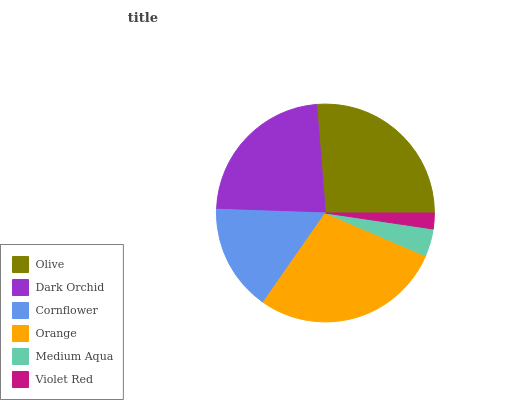Is Violet Red the minimum?
Answer yes or no. Yes. Is Orange the maximum?
Answer yes or no. Yes. Is Dark Orchid the minimum?
Answer yes or no. No. Is Dark Orchid the maximum?
Answer yes or no. No. Is Olive greater than Dark Orchid?
Answer yes or no. Yes. Is Dark Orchid less than Olive?
Answer yes or no. Yes. Is Dark Orchid greater than Olive?
Answer yes or no. No. Is Olive less than Dark Orchid?
Answer yes or no. No. Is Dark Orchid the high median?
Answer yes or no. Yes. Is Cornflower the low median?
Answer yes or no. Yes. Is Cornflower the high median?
Answer yes or no. No. Is Orange the low median?
Answer yes or no. No. 